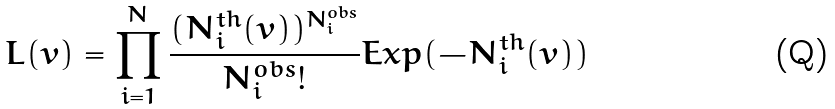<formula> <loc_0><loc_0><loc_500><loc_500>L ( { v } ) = \prod _ { i = 1 } ^ { N } \frac { ( { N ^ { t h } _ { i } ( v } ) ) ^ { N ^ { o b s } _ { i } } } { N ^ { o b s } _ { i } ! } E x p ( { - N ^ { t h } _ { i } ( v } ) ) \,</formula> 